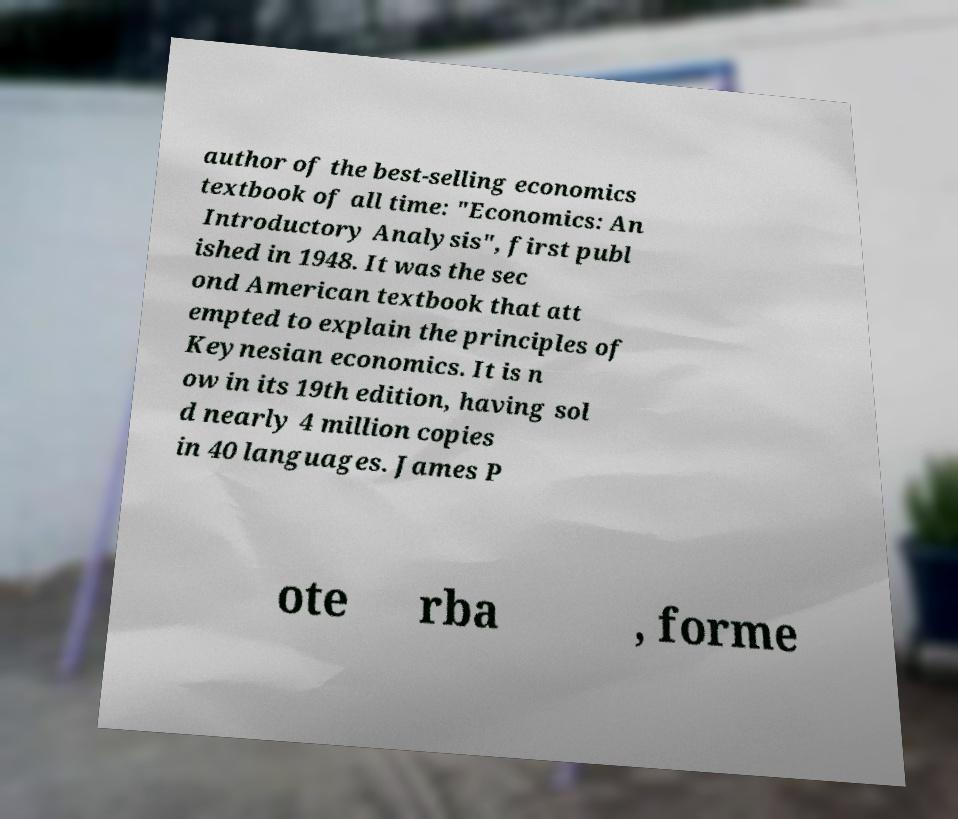I need the written content from this picture converted into text. Can you do that? author of the best-selling economics textbook of all time: "Economics: An Introductory Analysis", first publ ished in 1948. It was the sec ond American textbook that att empted to explain the principles of Keynesian economics. It is n ow in its 19th edition, having sol d nearly 4 million copies in 40 languages. James P ote rba , forme 